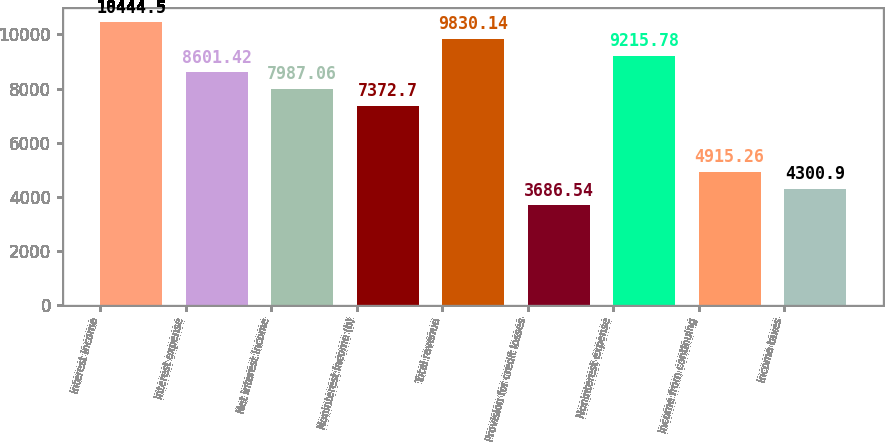Convert chart. <chart><loc_0><loc_0><loc_500><loc_500><bar_chart><fcel>Interest income<fcel>Interest expense<fcel>Net interest income<fcel>Noninterest income (b)<fcel>Total revenue<fcel>Provision for credit losses<fcel>Noninterest expense<fcel>Income from continuing<fcel>Income taxes<nl><fcel>10444.5<fcel>8601.42<fcel>7987.06<fcel>7372.7<fcel>9830.14<fcel>3686.54<fcel>9215.78<fcel>4915.26<fcel>4300.9<nl></chart> 